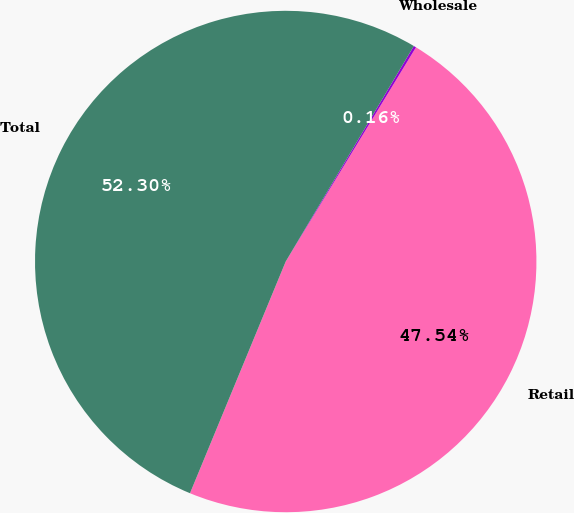Convert chart. <chart><loc_0><loc_0><loc_500><loc_500><pie_chart><fcel>Retail<fcel>Wholesale<fcel>Total<nl><fcel>47.54%<fcel>0.16%<fcel>52.3%<nl></chart> 